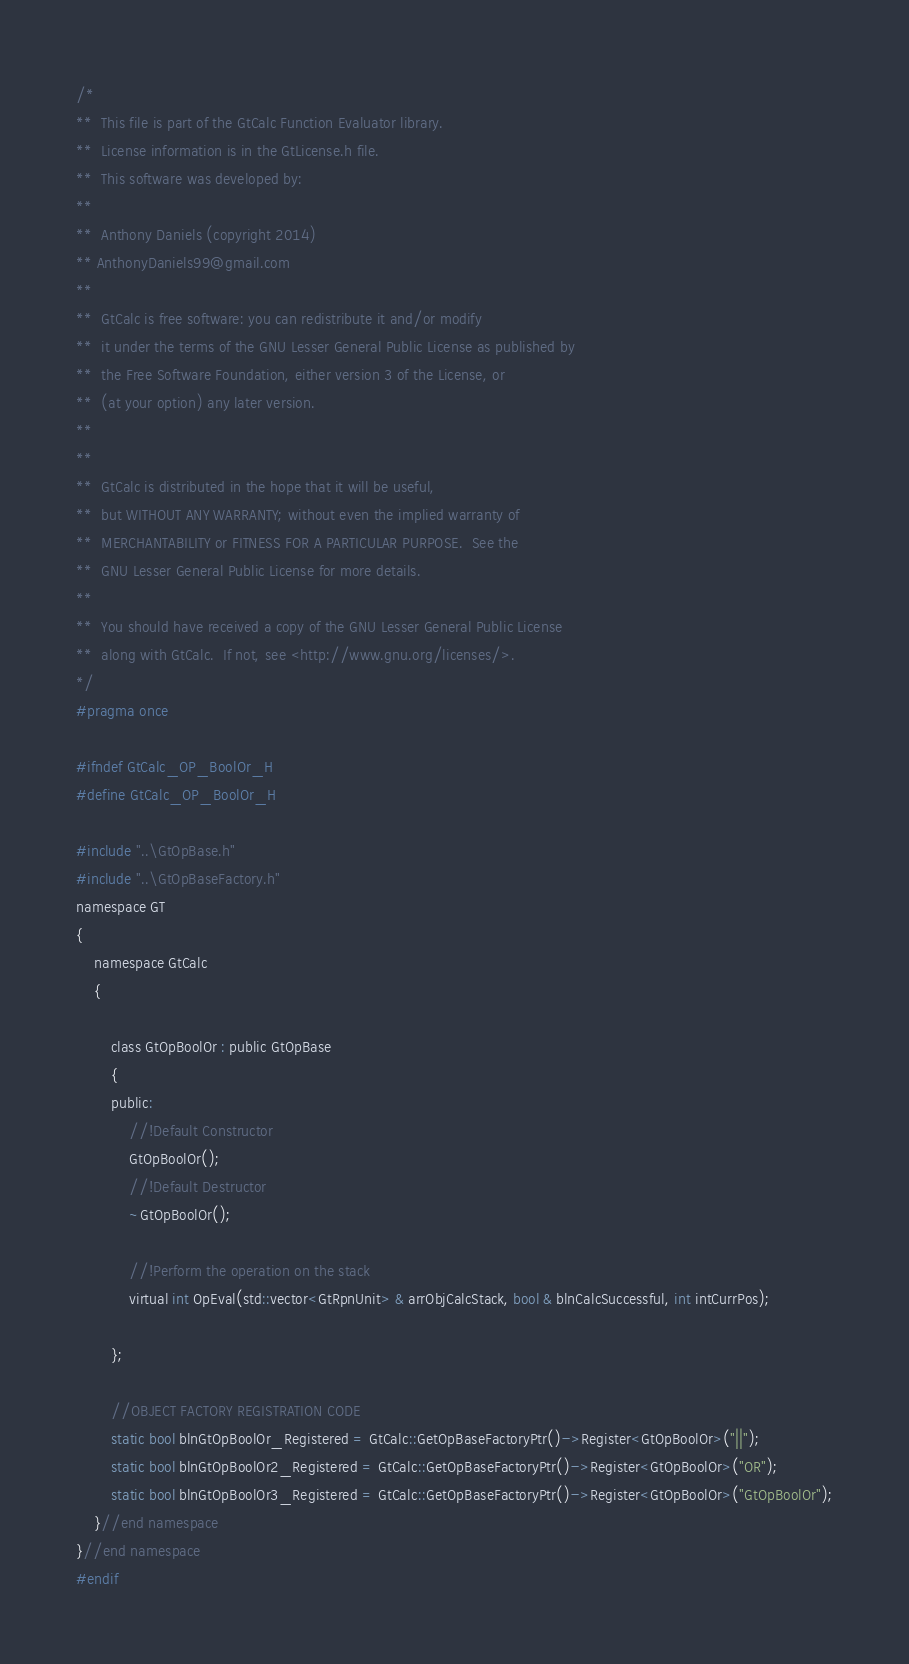<code> <loc_0><loc_0><loc_500><loc_500><_C_>/*
**	This file is part of the GtCalc Function Evaluator library.
**  License information is in the GtLicense.h file.
**	This software was developed by:
**	
**  Anthony Daniels (copyright 2014)
** AnthonyDaniels99@gmail.com
**
**  GtCalc is free software: you can redistribute it and/or modify
**  it under the terms of the GNU Lesser General Public License as published by
**  the Free Software Foundation, either version 3 of the License, or
**  (at your option) any later version.
**
**
**  GtCalc is distributed in the hope that it will be useful,
**  but WITHOUT ANY WARRANTY; without even the implied warranty of
**  MERCHANTABILITY or FITNESS FOR A PARTICULAR PURPOSE.  See the
**  GNU Lesser General Public License for more details.
**
**  You should have received a copy of the GNU Lesser General Public License
**  along with GtCalc.  If not, see <http://www.gnu.org/licenses/>.
*/
#pragma once

#ifndef GtCalc_OP_BoolOr_H
#define GtCalc_OP_BoolOr_H

#include "..\GtOpBase.h"
#include "..\GtOpBaseFactory.h"
namespace GT
{
	namespace GtCalc
	{

		class GtOpBoolOr : public GtOpBase
		{
		public:
			//!Default Constructor
			GtOpBoolOr();
			//!Default Destructor
			~GtOpBoolOr();

			//!Perform the operation on the stack
			virtual int OpEval(std::vector<GtRpnUnit> & arrObjCalcStack, bool & blnCalcSuccessful, int intCurrPos);

		};

		//OBJECT FACTORY REGISTRATION CODE
		static bool blnGtOpBoolOr_Registered = GtCalc::GetOpBaseFactoryPtr()->Register<GtOpBoolOr>("||");
		static bool blnGtOpBoolOr2_Registered = GtCalc::GetOpBaseFactoryPtr()->Register<GtOpBoolOr>("OR");
		static bool blnGtOpBoolOr3_Registered = GtCalc::GetOpBaseFactoryPtr()->Register<GtOpBoolOr>("GtOpBoolOr");
	}//end namespace
}//end namespace
#endif</code> 